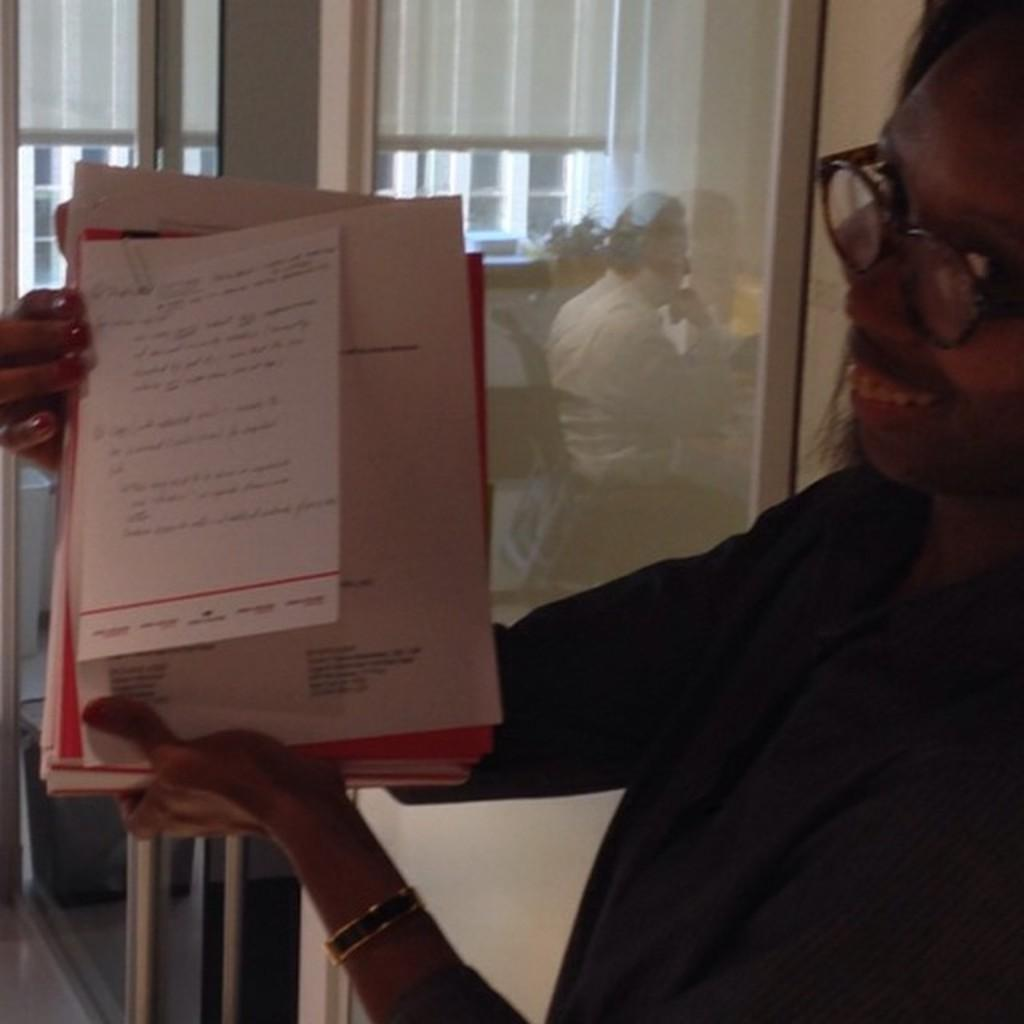Who is present in the image? There is a woman in the image. What is the woman holding in her hand? The woman is holding papers in her hand. What can be seen in the background of the image? There is a glass door in the background of the image. What is the man in the image doing? The man is sitting on a chair and is reflecting on the glass door. What type of polish is the woman applying to her nails in the image? There is no indication in the image that the woman is applying polish to her nails, as she is holding papers. 